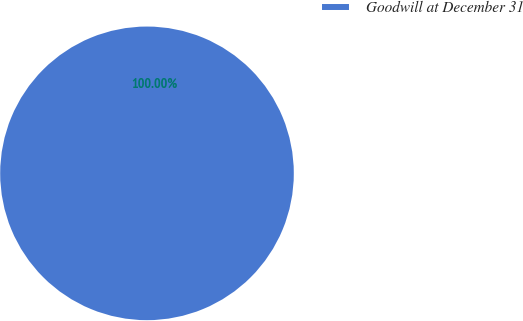<chart> <loc_0><loc_0><loc_500><loc_500><pie_chart><fcel>Goodwill at December 31<nl><fcel>100.0%<nl></chart> 